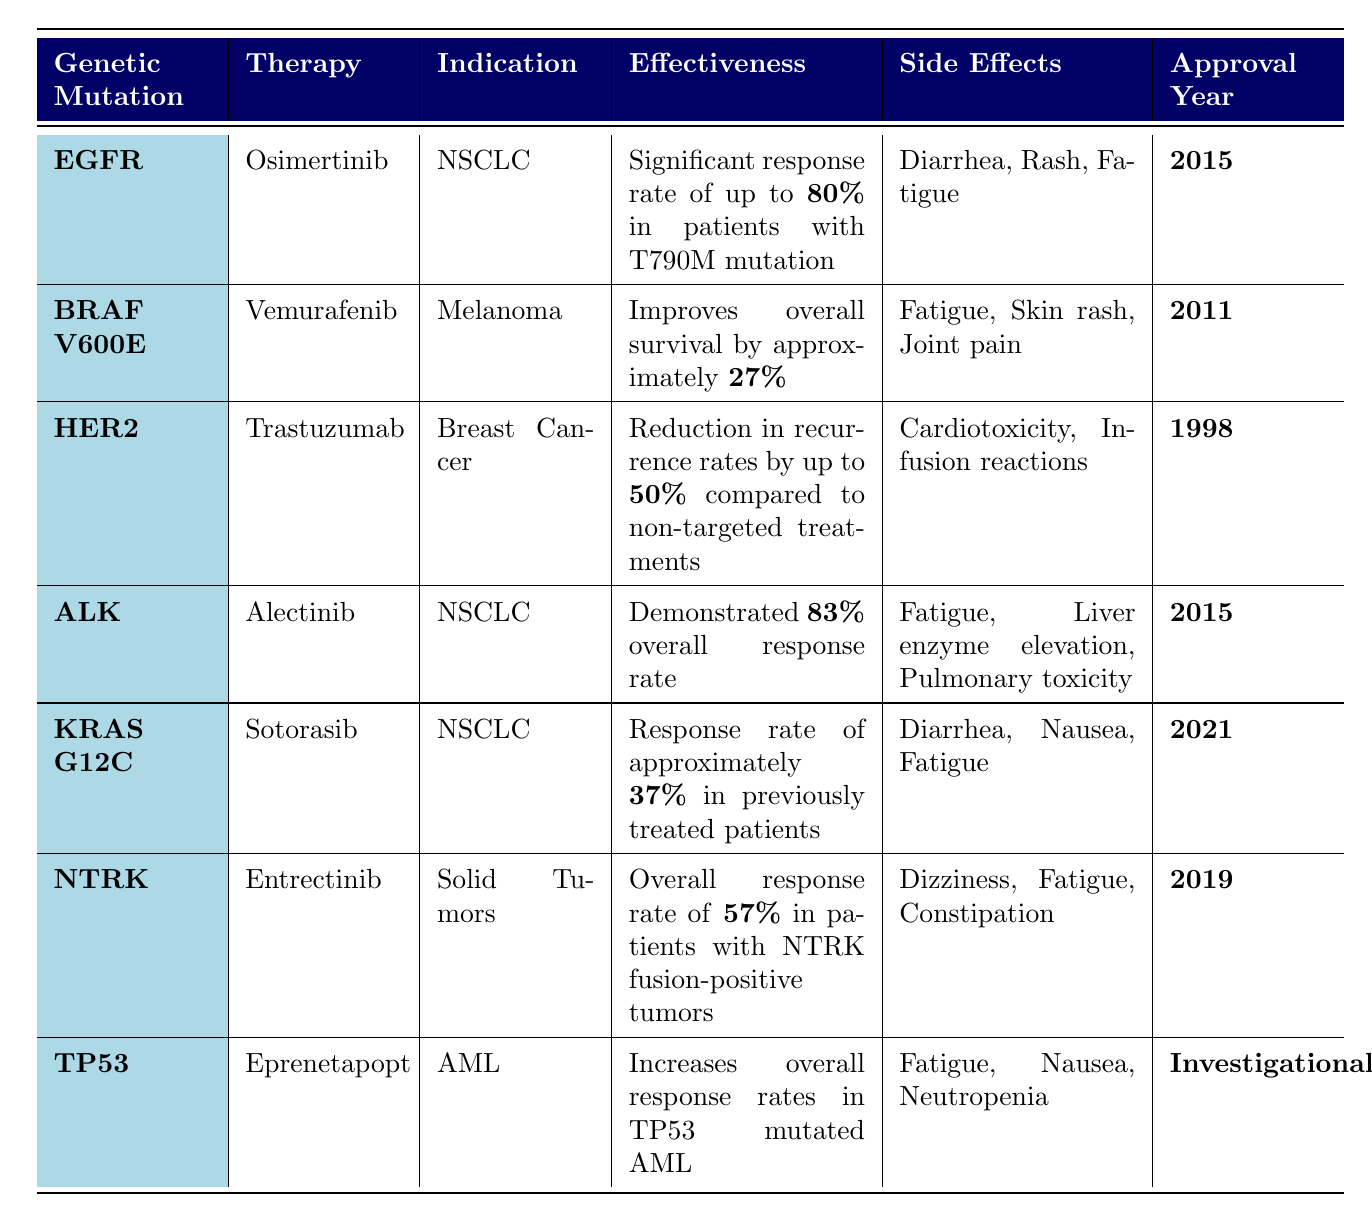What is the therapy for the genetic mutation ALK? In the table, under the row for the genetic mutation ALK, the therapy listed is Alectinib.
Answer: Alectinib What are the side effects of the therapy for HER2 mutation? Looking at the HER2 mutation entry, the side effects listed are Cardiotoxicity and Infusion reactions.
Answer: Cardiotoxicity, Infusion reactions Which therapy has the highest effectiveness reported? The therapy with the highest effectiveness is Osimertinib for the EGFR mutation, which states a significant response rate of up to 80%.
Answer: Osimertinib How many therapies were approved in 2015? There are two therapies listed with approval years marked as 2015: Osimertinib and Alectinib.
Answer: 2 Is Eprenetapopt approved for patients with the TP53 mutation? The table shows that Eprenetapopt is listed as investigational for the TP53 mutation, indicating it is not yet approved.
Answer: No What is the approval year for Vemurafenib? Referring to the entry for BRAF V600E, Vemurafenib was approved in 2011.
Answer: 2011 Is the overall response rate for NTRK patients higher or lower than 50%? The NTRK entry indicates an overall response rate of 57%, which is higher than 50%.
Answer: Higher Which mutation has an effectiveness of approximately 37%? The KRAS G12C entry mentions a response rate of approximately 37% in previously treated patients.
Answer: KRAS G12C What therapy is indicated for Acute Myeloid Leukemia? The TP53 entry indicates that Eprenetapopt is the therapy used for Acute Myeloid Leukemia (AML).
Answer: Eprenetapopt Which mutation and therapy combination has shown an 83% overall response rate? The ALK mutation paired with the therapy Alectinib shows an effectiveness of an 83% overall response rate according to the table.
Answer: ALK and Alectinib What percentage improvement in overall survival is reported for Vemurafenib? The effectiveness for Vemurafenib indicates an improvement in overall survival of approximately 27%.
Answer: 27% 